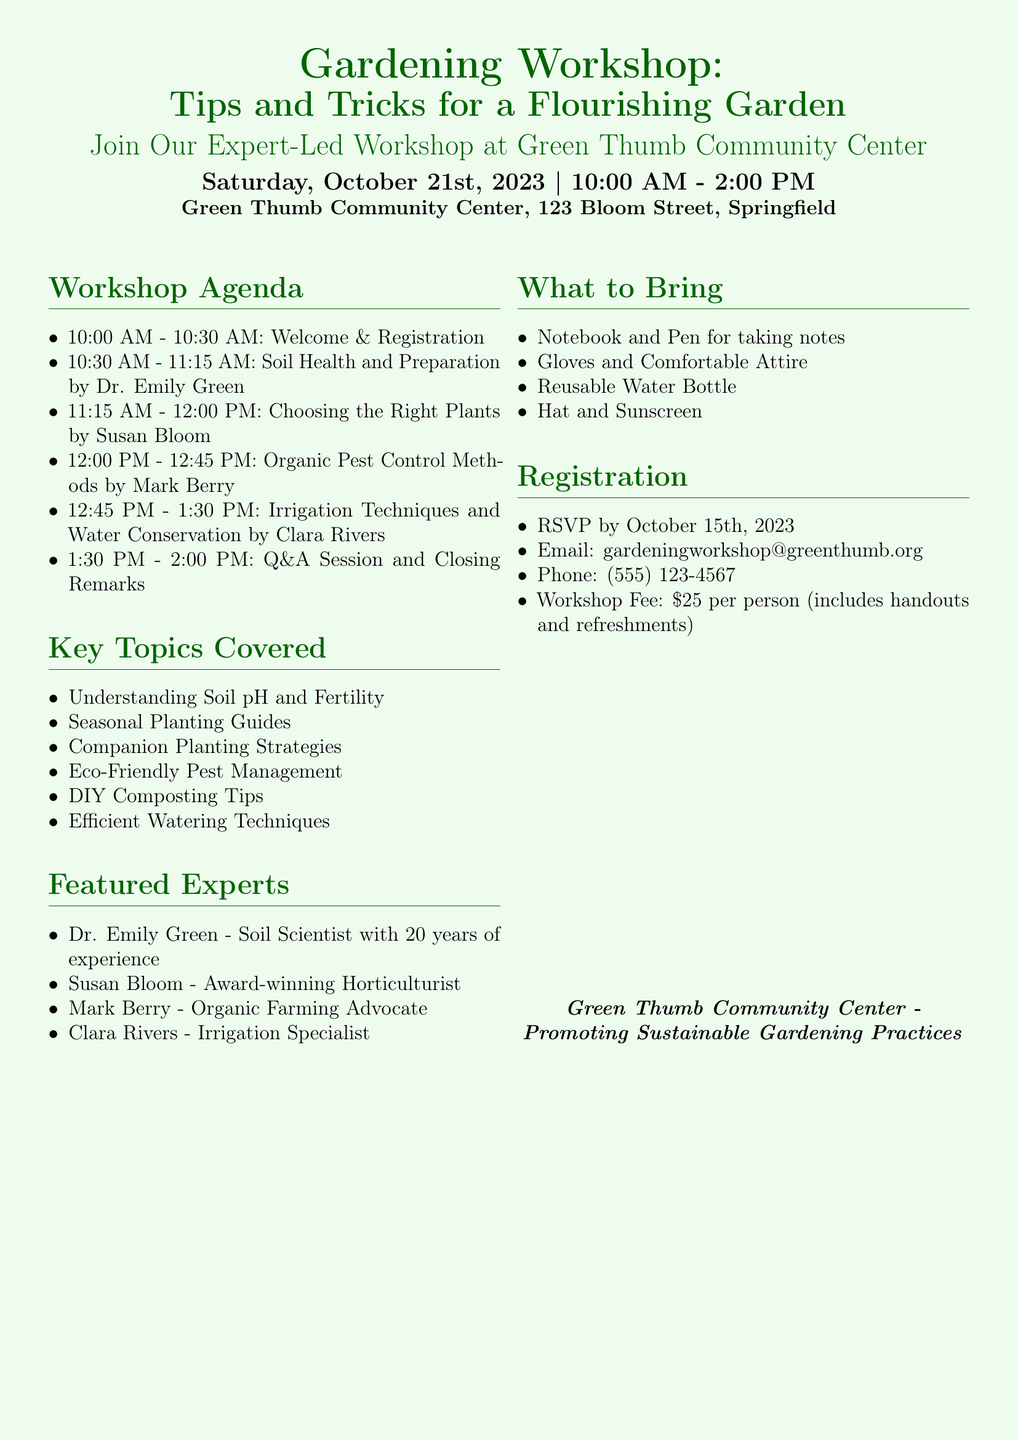What is the date of the workshop? The date of the workshop is mentioned at the beginning of the document.
Answer: October 21st, 2023 What time does the workshop start? The starting time of the workshop is indicated in the schedule section.
Answer: 10:00 AM Who is leading the session on soil health? The name of the expert leading that session is listed in the agenda section.
Answer: Dr. Emily Green What is the workshop fee? The fee for attending the workshop is specified in the registration section.
Answer: $25 per person What is one item participants should bring? The document lists several items to bring under the "What to Bring" section.
Answer: Notebook and Pen Which topic covers pest management? The topics covered in the workshop are outlined, and one explicitly mentions pest management.
Answer: Eco-Friendly Pest Management What is the name of the community center hosting the workshop? The hosting community center is mentioned at the very beginning of the document.
Answer: Green Thumb Community Center When is the RSVP deadline? The RSVP deadline is clearly stated in the registration section of the flyer.
Answer: October 15th, 2023 